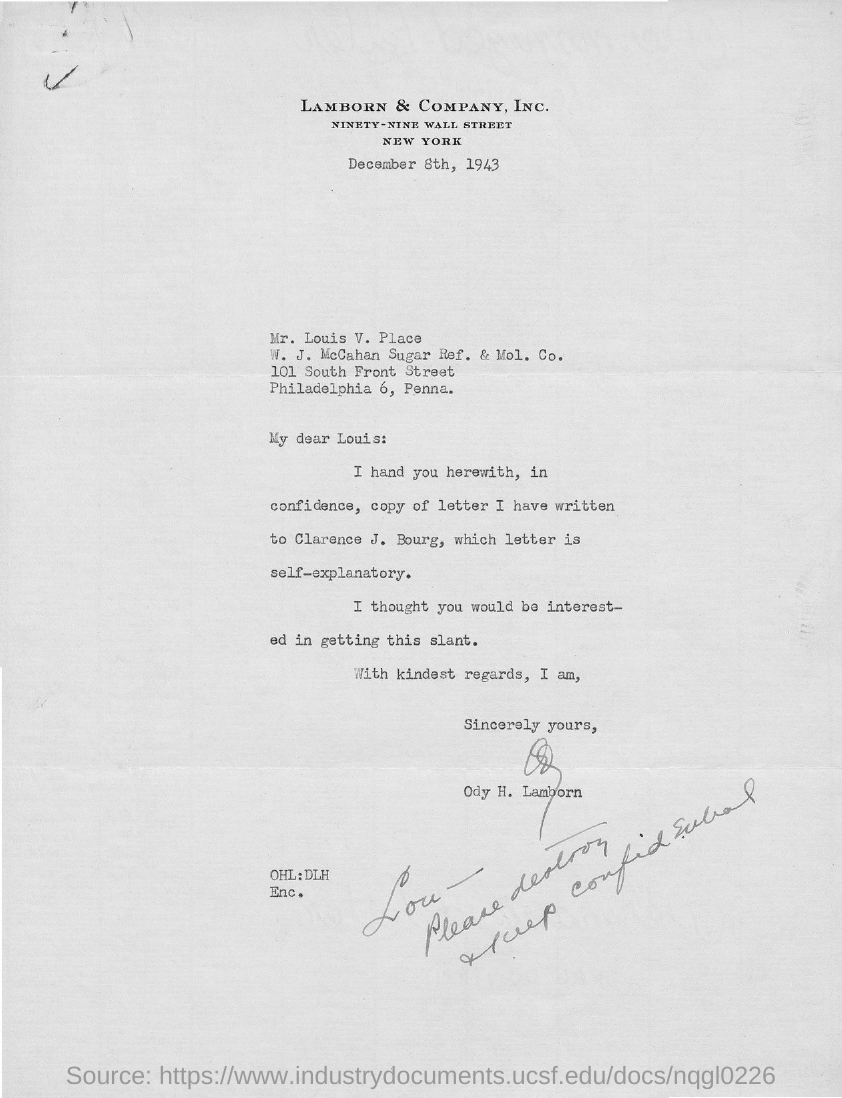What is the date on the document?
Offer a very short reply. DECEMBER 8TH, 1943. To Whom is this letter addressed to?
Provide a succinct answer. Mr. Louis V. Place. Who is this letter from?
Provide a succinct answer. ODY H. LAMBORN. 